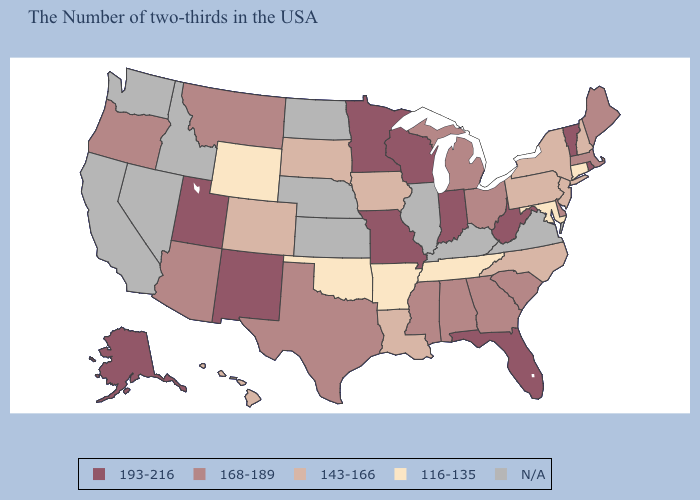Does the map have missing data?
Keep it brief. Yes. Among the states that border Ohio , does Indiana have the lowest value?
Give a very brief answer. No. How many symbols are there in the legend?
Keep it brief. 5. Among the states that border Colorado , does Utah have the lowest value?
Concise answer only. No. What is the value of New York?
Give a very brief answer. 143-166. Name the states that have a value in the range N/A?
Answer briefly. Virginia, Kentucky, Illinois, Kansas, Nebraska, North Dakota, Idaho, Nevada, California, Washington. What is the value of Wyoming?
Answer briefly. 116-135. Name the states that have a value in the range 116-135?
Be succinct. Connecticut, Maryland, Tennessee, Arkansas, Oklahoma, Wyoming. Is the legend a continuous bar?
Write a very short answer. No. What is the highest value in the USA?
Write a very short answer. 193-216. Name the states that have a value in the range 143-166?
Answer briefly. New Hampshire, New York, New Jersey, Pennsylvania, North Carolina, Louisiana, Iowa, South Dakota, Colorado, Hawaii. What is the highest value in the USA?
Quick response, please. 193-216. What is the lowest value in states that border Wisconsin?
Give a very brief answer. 143-166. What is the value of Alabama?
Concise answer only. 168-189. What is the value of Ohio?
Give a very brief answer. 168-189. 